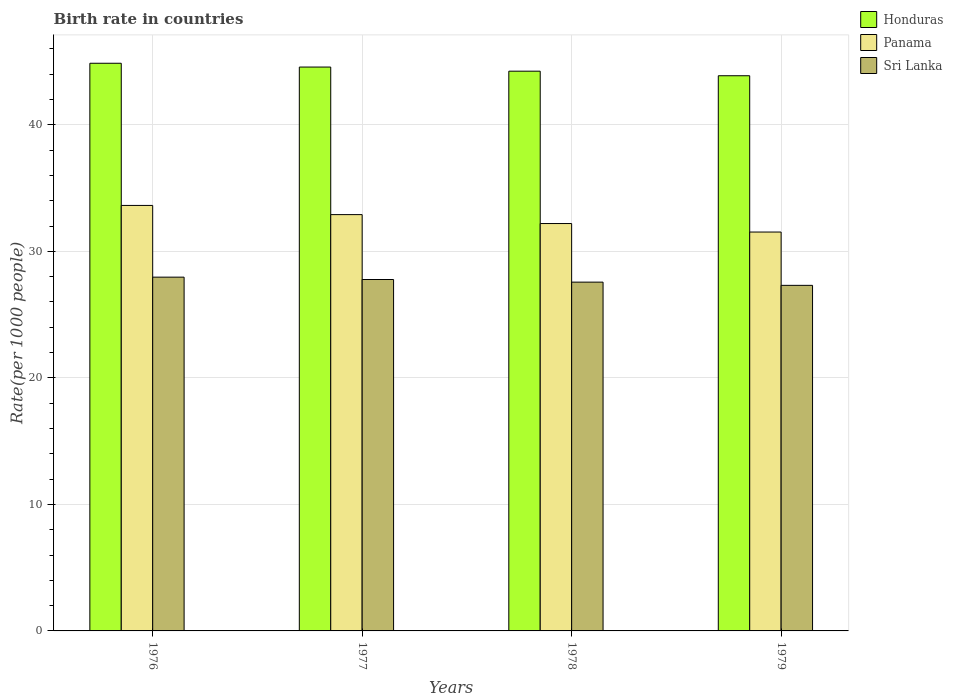How many different coloured bars are there?
Provide a succinct answer. 3. How many bars are there on the 2nd tick from the left?
Your answer should be compact. 3. How many bars are there on the 4th tick from the right?
Make the answer very short. 3. What is the label of the 3rd group of bars from the left?
Your response must be concise. 1978. In how many cases, is the number of bars for a given year not equal to the number of legend labels?
Provide a succinct answer. 0. What is the birth rate in Panama in 1979?
Your response must be concise. 31.53. Across all years, what is the maximum birth rate in Sri Lanka?
Offer a very short reply. 27.96. Across all years, what is the minimum birth rate in Sri Lanka?
Provide a short and direct response. 27.32. In which year was the birth rate in Sri Lanka maximum?
Give a very brief answer. 1976. In which year was the birth rate in Sri Lanka minimum?
Your response must be concise. 1979. What is the total birth rate in Honduras in the graph?
Provide a short and direct response. 177.57. What is the difference between the birth rate in Honduras in 1976 and that in 1979?
Offer a terse response. 0.99. What is the difference between the birth rate in Sri Lanka in 1977 and the birth rate in Panama in 1979?
Ensure brevity in your answer.  -3.75. What is the average birth rate in Panama per year?
Provide a succinct answer. 32.57. In the year 1979, what is the difference between the birth rate in Panama and birth rate in Honduras?
Give a very brief answer. -12.35. In how many years, is the birth rate in Sri Lanka greater than 42?
Offer a very short reply. 0. What is the ratio of the birth rate in Panama in 1978 to that in 1979?
Offer a terse response. 1.02. Is the birth rate in Panama in 1977 less than that in 1979?
Offer a terse response. No. Is the difference between the birth rate in Panama in 1977 and 1978 greater than the difference between the birth rate in Honduras in 1977 and 1978?
Offer a very short reply. Yes. What is the difference between the highest and the second highest birth rate in Honduras?
Your response must be concise. 0.3. What is the difference between the highest and the lowest birth rate in Panama?
Provide a short and direct response. 2.1. In how many years, is the birth rate in Sri Lanka greater than the average birth rate in Sri Lanka taken over all years?
Your answer should be very brief. 2. Is the sum of the birth rate in Sri Lanka in 1976 and 1979 greater than the maximum birth rate in Panama across all years?
Keep it short and to the point. Yes. What does the 1st bar from the left in 1979 represents?
Offer a very short reply. Honduras. What does the 1st bar from the right in 1979 represents?
Keep it short and to the point. Sri Lanka. Are all the bars in the graph horizontal?
Your answer should be compact. No. What is the difference between two consecutive major ticks on the Y-axis?
Make the answer very short. 10. Does the graph contain any zero values?
Provide a succinct answer. No. Does the graph contain grids?
Offer a terse response. Yes. What is the title of the graph?
Keep it short and to the point. Birth rate in countries. Does "Mexico" appear as one of the legend labels in the graph?
Provide a short and direct response. No. What is the label or title of the Y-axis?
Your answer should be compact. Rate(per 1000 people). What is the Rate(per 1000 people) in Honduras in 1976?
Provide a short and direct response. 44.87. What is the Rate(per 1000 people) in Panama in 1976?
Offer a terse response. 33.63. What is the Rate(per 1000 people) in Sri Lanka in 1976?
Keep it short and to the point. 27.96. What is the Rate(per 1000 people) of Honduras in 1977?
Give a very brief answer. 44.57. What is the Rate(per 1000 people) in Panama in 1977?
Provide a succinct answer. 32.91. What is the Rate(per 1000 people) in Sri Lanka in 1977?
Your answer should be compact. 27.78. What is the Rate(per 1000 people) in Honduras in 1978?
Give a very brief answer. 44.24. What is the Rate(per 1000 people) of Panama in 1978?
Your answer should be compact. 32.2. What is the Rate(per 1000 people) in Sri Lanka in 1978?
Your answer should be very brief. 27.57. What is the Rate(per 1000 people) in Honduras in 1979?
Give a very brief answer. 43.88. What is the Rate(per 1000 people) in Panama in 1979?
Provide a succinct answer. 31.53. What is the Rate(per 1000 people) in Sri Lanka in 1979?
Ensure brevity in your answer.  27.32. Across all years, what is the maximum Rate(per 1000 people) of Honduras?
Give a very brief answer. 44.87. Across all years, what is the maximum Rate(per 1000 people) of Panama?
Provide a succinct answer. 33.63. Across all years, what is the maximum Rate(per 1000 people) of Sri Lanka?
Your answer should be very brief. 27.96. Across all years, what is the minimum Rate(per 1000 people) of Honduras?
Provide a short and direct response. 43.88. Across all years, what is the minimum Rate(per 1000 people) of Panama?
Offer a very short reply. 31.53. Across all years, what is the minimum Rate(per 1000 people) in Sri Lanka?
Your answer should be very brief. 27.32. What is the total Rate(per 1000 people) in Honduras in the graph?
Your response must be concise. 177.57. What is the total Rate(per 1000 people) of Panama in the graph?
Provide a succinct answer. 130.27. What is the total Rate(per 1000 people) in Sri Lanka in the graph?
Provide a short and direct response. 110.62. What is the difference between the Rate(per 1000 people) of Honduras in 1976 and that in 1977?
Offer a terse response. 0.3. What is the difference between the Rate(per 1000 people) in Panama in 1976 and that in 1977?
Make the answer very short. 0.73. What is the difference between the Rate(per 1000 people) in Sri Lanka in 1976 and that in 1977?
Make the answer very short. 0.19. What is the difference between the Rate(per 1000 people) of Honduras in 1976 and that in 1978?
Your answer should be compact. 0.63. What is the difference between the Rate(per 1000 people) in Panama in 1976 and that in 1978?
Keep it short and to the point. 1.43. What is the difference between the Rate(per 1000 people) of Sri Lanka in 1976 and that in 1978?
Your response must be concise. 0.39. What is the difference between the Rate(per 1000 people) of Panama in 1976 and that in 1979?
Make the answer very short. 2.1. What is the difference between the Rate(per 1000 people) in Sri Lanka in 1976 and that in 1979?
Provide a short and direct response. 0.65. What is the difference between the Rate(per 1000 people) in Honduras in 1977 and that in 1978?
Provide a succinct answer. 0.33. What is the difference between the Rate(per 1000 people) in Panama in 1977 and that in 1978?
Make the answer very short. 0.7. What is the difference between the Rate(per 1000 people) in Sri Lanka in 1977 and that in 1978?
Provide a short and direct response. 0.21. What is the difference between the Rate(per 1000 people) in Honduras in 1977 and that in 1979?
Provide a short and direct response. 0.69. What is the difference between the Rate(per 1000 people) of Panama in 1977 and that in 1979?
Provide a succinct answer. 1.38. What is the difference between the Rate(per 1000 people) in Sri Lanka in 1977 and that in 1979?
Your response must be concise. 0.46. What is the difference between the Rate(per 1000 people) of Honduras in 1978 and that in 1979?
Your answer should be compact. 0.36. What is the difference between the Rate(per 1000 people) in Panama in 1978 and that in 1979?
Your answer should be compact. 0.67. What is the difference between the Rate(per 1000 people) of Sri Lanka in 1978 and that in 1979?
Offer a very short reply. 0.26. What is the difference between the Rate(per 1000 people) of Honduras in 1976 and the Rate(per 1000 people) of Panama in 1977?
Make the answer very short. 11.96. What is the difference between the Rate(per 1000 people) of Honduras in 1976 and the Rate(per 1000 people) of Sri Lanka in 1977?
Keep it short and to the point. 17.09. What is the difference between the Rate(per 1000 people) of Panama in 1976 and the Rate(per 1000 people) of Sri Lanka in 1977?
Give a very brief answer. 5.86. What is the difference between the Rate(per 1000 people) of Honduras in 1976 and the Rate(per 1000 people) of Panama in 1978?
Offer a very short reply. 12.67. What is the difference between the Rate(per 1000 people) of Panama in 1976 and the Rate(per 1000 people) of Sri Lanka in 1978?
Your answer should be very brief. 6.06. What is the difference between the Rate(per 1000 people) of Honduras in 1976 and the Rate(per 1000 people) of Panama in 1979?
Offer a very short reply. 13.34. What is the difference between the Rate(per 1000 people) of Honduras in 1976 and the Rate(per 1000 people) of Sri Lanka in 1979?
Your response must be concise. 17.55. What is the difference between the Rate(per 1000 people) in Panama in 1976 and the Rate(per 1000 people) in Sri Lanka in 1979?
Keep it short and to the point. 6.32. What is the difference between the Rate(per 1000 people) in Honduras in 1977 and the Rate(per 1000 people) in Panama in 1978?
Provide a short and direct response. 12.37. What is the difference between the Rate(per 1000 people) in Panama in 1977 and the Rate(per 1000 people) in Sri Lanka in 1978?
Offer a very short reply. 5.34. What is the difference between the Rate(per 1000 people) in Honduras in 1977 and the Rate(per 1000 people) in Panama in 1979?
Ensure brevity in your answer.  13.04. What is the difference between the Rate(per 1000 people) in Honduras in 1977 and the Rate(per 1000 people) in Sri Lanka in 1979?
Your response must be concise. 17.25. What is the difference between the Rate(per 1000 people) of Panama in 1977 and the Rate(per 1000 people) of Sri Lanka in 1979?
Give a very brief answer. 5.59. What is the difference between the Rate(per 1000 people) in Honduras in 1978 and the Rate(per 1000 people) in Panama in 1979?
Your answer should be very brief. 12.71. What is the difference between the Rate(per 1000 people) of Honduras in 1978 and the Rate(per 1000 people) of Sri Lanka in 1979?
Give a very brief answer. 16.93. What is the difference between the Rate(per 1000 people) in Panama in 1978 and the Rate(per 1000 people) in Sri Lanka in 1979?
Offer a terse response. 4.89. What is the average Rate(per 1000 people) of Honduras per year?
Offer a terse response. 44.39. What is the average Rate(per 1000 people) in Panama per year?
Provide a succinct answer. 32.57. What is the average Rate(per 1000 people) in Sri Lanka per year?
Provide a succinct answer. 27.66. In the year 1976, what is the difference between the Rate(per 1000 people) of Honduras and Rate(per 1000 people) of Panama?
Make the answer very short. 11.24. In the year 1976, what is the difference between the Rate(per 1000 people) in Honduras and Rate(per 1000 people) in Sri Lanka?
Give a very brief answer. 16.91. In the year 1976, what is the difference between the Rate(per 1000 people) of Panama and Rate(per 1000 people) of Sri Lanka?
Keep it short and to the point. 5.67. In the year 1977, what is the difference between the Rate(per 1000 people) in Honduras and Rate(per 1000 people) in Panama?
Give a very brief answer. 11.66. In the year 1977, what is the difference between the Rate(per 1000 people) in Honduras and Rate(per 1000 people) in Sri Lanka?
Offer a very short reply. 16.79. In the year 1977, what is the difference between the Rate(per 1000 people) of Panama and Rate(per 1000 people) of Sri Lanka?
Keep it short and to the point. 5.13. In the year 1978, what is the difference between the Rate(per 1000 people) in Honduras and Rate(per 1000 people) in Panama?
Ensure brevity in your answer.  12.04. In the year 1978, what is the difference between the Rate(per 1000 people) in Honduras and Rate(per 1000 people) in Sri Lanka?
Give a very brief answer. 16.67. In the year 1978, what is the difference between the Rate(per 1000 people) of Panama and Rate(per 1000 people) of Sri Lanka?
Ensure brevity in your answer.  4.63. In the year 1979, what is the difference between the Rate(per 1000 people) in Honduras and Rate(per 1000 people) in Panama?
Offer a terse response. 12.35. In the year 1979, what is the difference between the Rate(per 1000 people) of Honduras and Rate(per 1000 people) of Sri Lanka?
Offer a very short reply. 16.57. In the year 1979, what is the difference between the Rate(per 1000 people) of Panama and Rate(per 1000 people) of Sri Lanka?
Ensure brevity in your answer.  4.21. What is the ratio of the Rate(per 1000 people) of Honduras in 1976 to that in 1977?
Provide a succinct answer. 1.01. What is the ratio of the Rate(per 1000 people) in Panama in 1976 to that in 1977?
Your answer should be very brief. 1.02. What is the ratio of the Rate(per 1000 people) in Honduras in 1976 to that in 1978?
Your response must be concise. 1.01. What is the ratio of the Rate(per 1000 people) in Panama in 1976 to that in 1978?
Offer a very short reply. 1.04. What is the ratio of the Rate(per 1000 people) of Sri Lanka in 1976 to that in 1978?
Ensure brevity in your answer.  1.01. What is the ratio of the Rate(per 1000 people) of Honduras in 1976 to that in 1979?
Make the answer very short. 1.02. What is the ratio of the Rate(per 1000 people) in Panama in 1976 to that in 1979?
Provide a short and direct response. 1.07. What is the ratio of the Rate(per 1000 people) in Sri Lanka in 1976 to that in 1979?
Offer a very short reply. 1.02. What is the ratio of the Rate(per 1000 people) in Honduras in 1977 to that in 1978?
Offer a very short reply. 1.01. What is the ratio of the Rate(per 1000 people) of Panama in 1977 to that in 1978?
Make the answer very short. 1.02. What is the ratio of the Rate(per 1000 people) in Sri Lanka in 1977 to that in 1978?
Keep it short and to the point. 1.01. What is the ratio of the Rate(per 1000 people) of Honduras in 1977 to that in 1979?
Your answer should be compact. 1.02. What is the ratio of the Rate(per 1000 people) of Panama in 1977 to that in 1979?
Offer a very short reply. 1.04. What is the ratio of the Rate(per 1000 people) in Sri Lanka in 1977 to that in 1979?
Your answer should be very brief. 1.02. What is the ratio of the Rate(per 1000 people) in Honduras in 1978 to that in 1979?
Give a very brief answer. 1.01. What is the ratio of the Rate(per 1000 people) of Panama in 1978 to that in 1979?
Your answer should be very brief. 1.02. What is the ratio of the Rate(per 1000 people) in Sri Lanka in 1978 to that in 1979?
Your response must be concise. 1.01. What is the difference between the highest and the second highest Rate(per 1000 people) in Panama?
Your answer should be very brief. 0.73. What is the difference between the highest and the second highest Rate(per 1000 people) in Sri Lanka?
Provide a short and direct response. 0.19. What is the difference between the highest and the lowest Rate(per 1000 people) in Honduras?
Your answer should be compact. 0.99. What is the difference between the highest and the lowest Rate(per 1000 people) in Panama?
Ensure brevity in your answer.  2.1. What is the difference between the highest and the lowest Rate(per 1000 people) in Sri Lanka?
Offer a terse response. 0.65. 